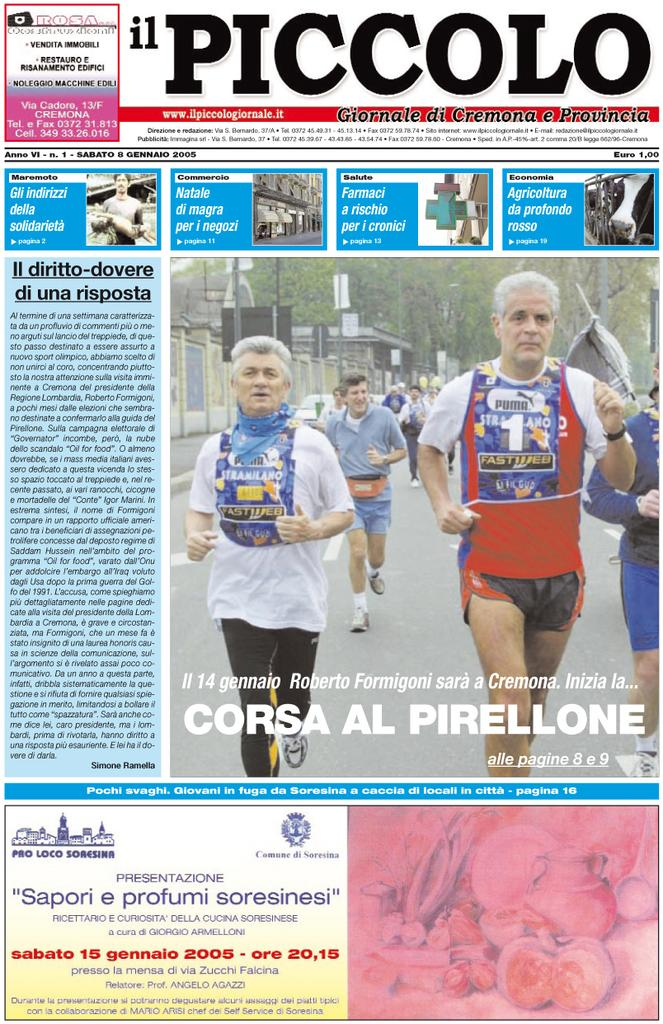What is the main subject of the image? The main subject of the image is a paper article. What type of content can be found in the paper article? The paper article contains images and text. What type of rail can be seen supporting the queen in the image? There is no queen or rail present in the image; it features a paper article with images and text. Can you tell me how many cats are depicted in the images within the paper article? There is no information about cats in the images or text within the paper article. 